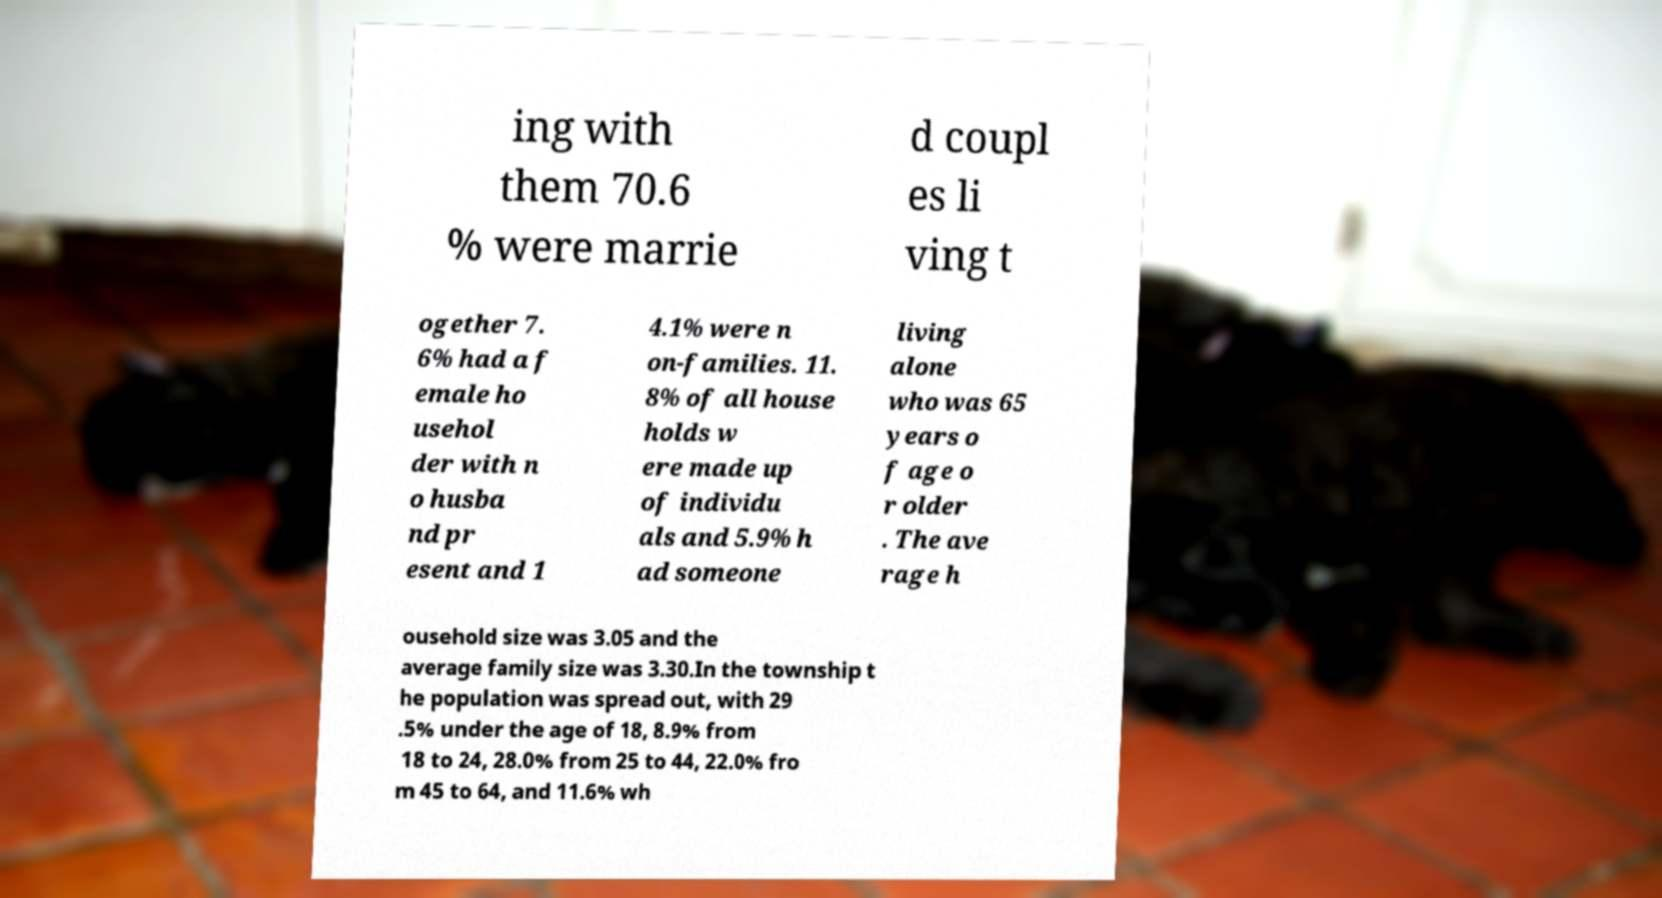Can you accurately transcribe the text from the provided image for me? ing with them 70.6 % were marrie d coupl es li ving t ogether 7. 6% had a f emale ho usehol der with n o husba nd pr esent and 1 4.1% were n on-families. 11. 8% of all house holds w ere made up of individu als and 5.9% h ad someone living alone who was 65 years o f age o r older . The ave rage h ousehold size was 3.05 and the average family size was 3.30.In the township t he population was spread out, with 29 .5% under the age of 18, 8.9% from 18 to 24, 28.0% from 25 to 44, 22.0% fro m 45 to 64, and 11.6% wh 